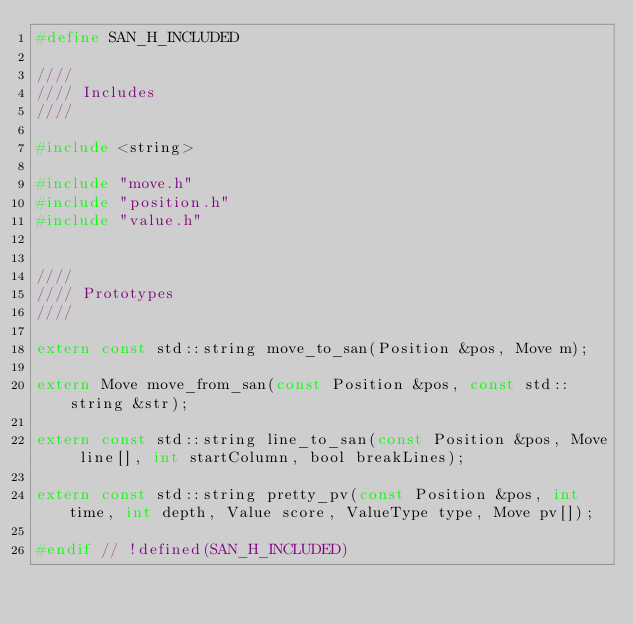Convert code to text. <code><loc_0><loc_0><loc_500><loc_500><_C_>#define SAN_H_INCLUDED

////
//// Includes
////

#include <string>

#include "move.h"
#include "position.h"
#include "value.h"


////
//// Prototypes
////

extern const std::string move_to_san(Position &pos, Move m);

extern Move move_from_san(const Position &pos, const std::string &str);

extern const std::string line_to_san(const Position &pos, Move line[], int startColumn, bool breakLines);

extern const std::string pretty_pv(const Position &pos, int time, int depth, Value score, ValueType type, Move pv[]);

#endif // !defined(SAN_H_INCLUDED)
</code> 